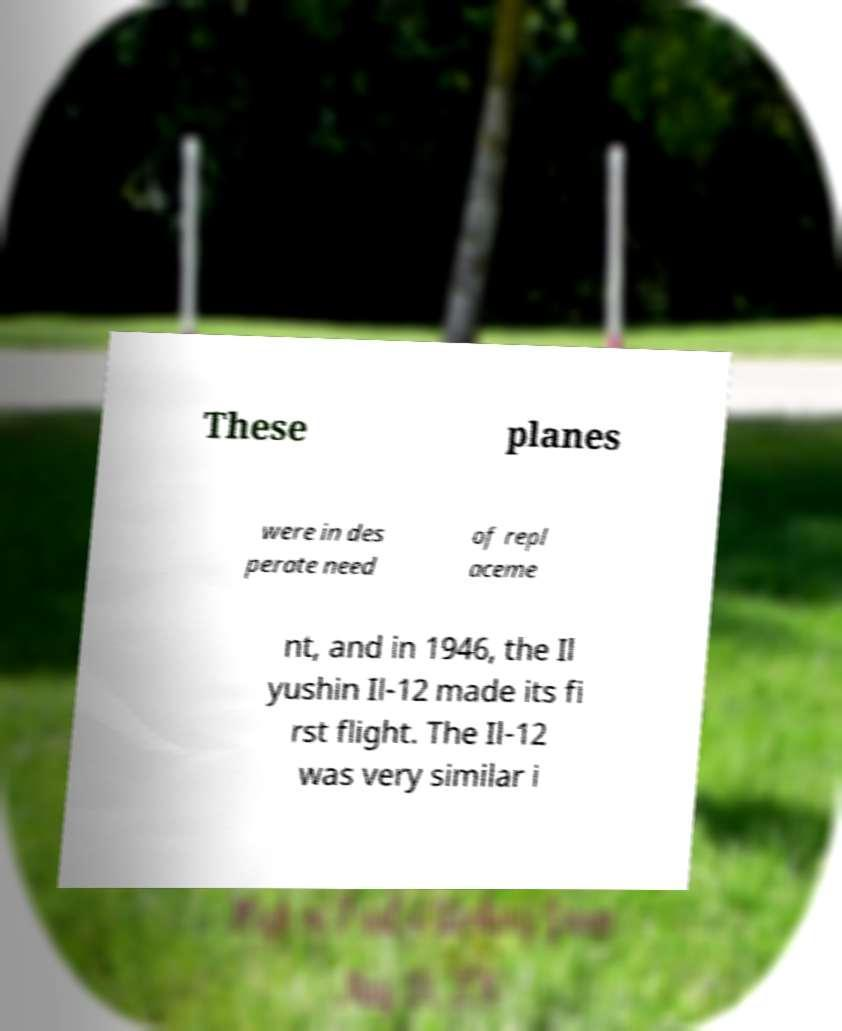What messages or text are displayed in this image? I need them in a readable, typed format. These planes were in des perate need of repl aceme nt, and in 1946, the Il yushin Il-12 made its fi rst flight. The Il-12 was very similar i 